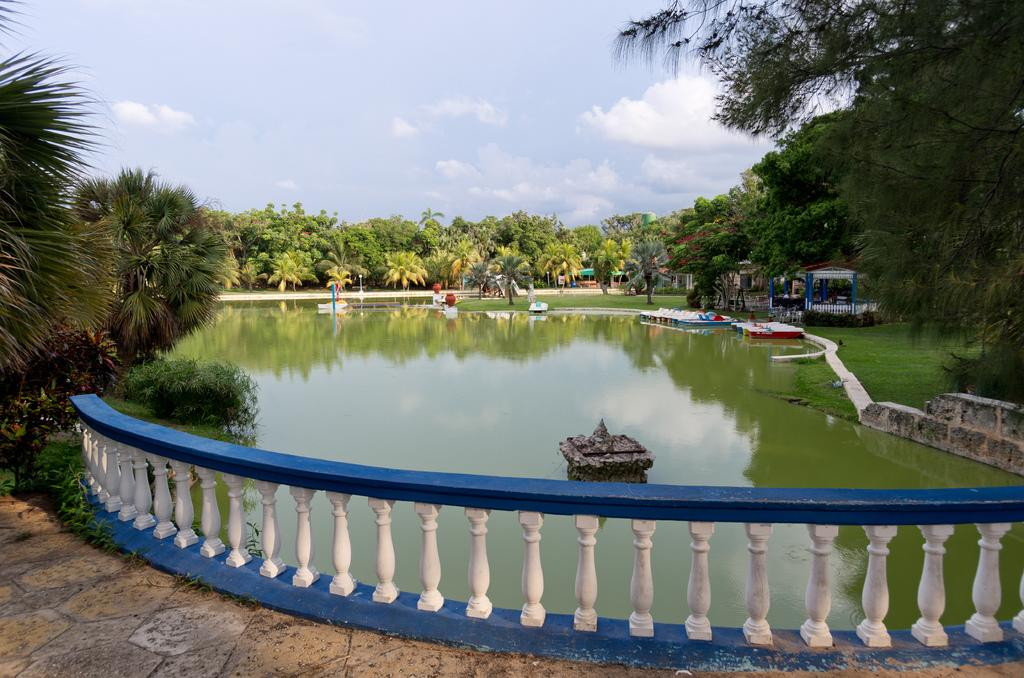What type of body of water is present in the image? There is a water lake in the image. What is surrounding the lake? There is a fence around the lake. What type of vegetation can be seen in the image? There are trees visible in the image. What is visible above the lake and trees? The sky is visible in the image. Can you see any matches being lit by the minister near the ant in the image? There are no matches, minister, or ants present in the image. 